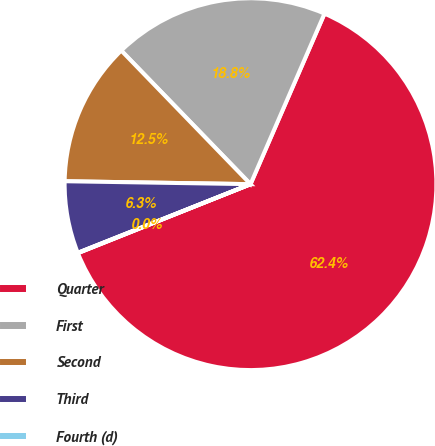Convert chart to OTSL. <chart><loc_0><loc_0><loc_500><loc_500><pie_chart><fcel>Quarter<fcel>First<fcel>Second<fcel>Third<fcel>Fourth (d)<nl><fcel>62.43%<fcel>18.75%<fcel>12.51%<fcel>6.27%<fcel>0.03%<nl></chart> 